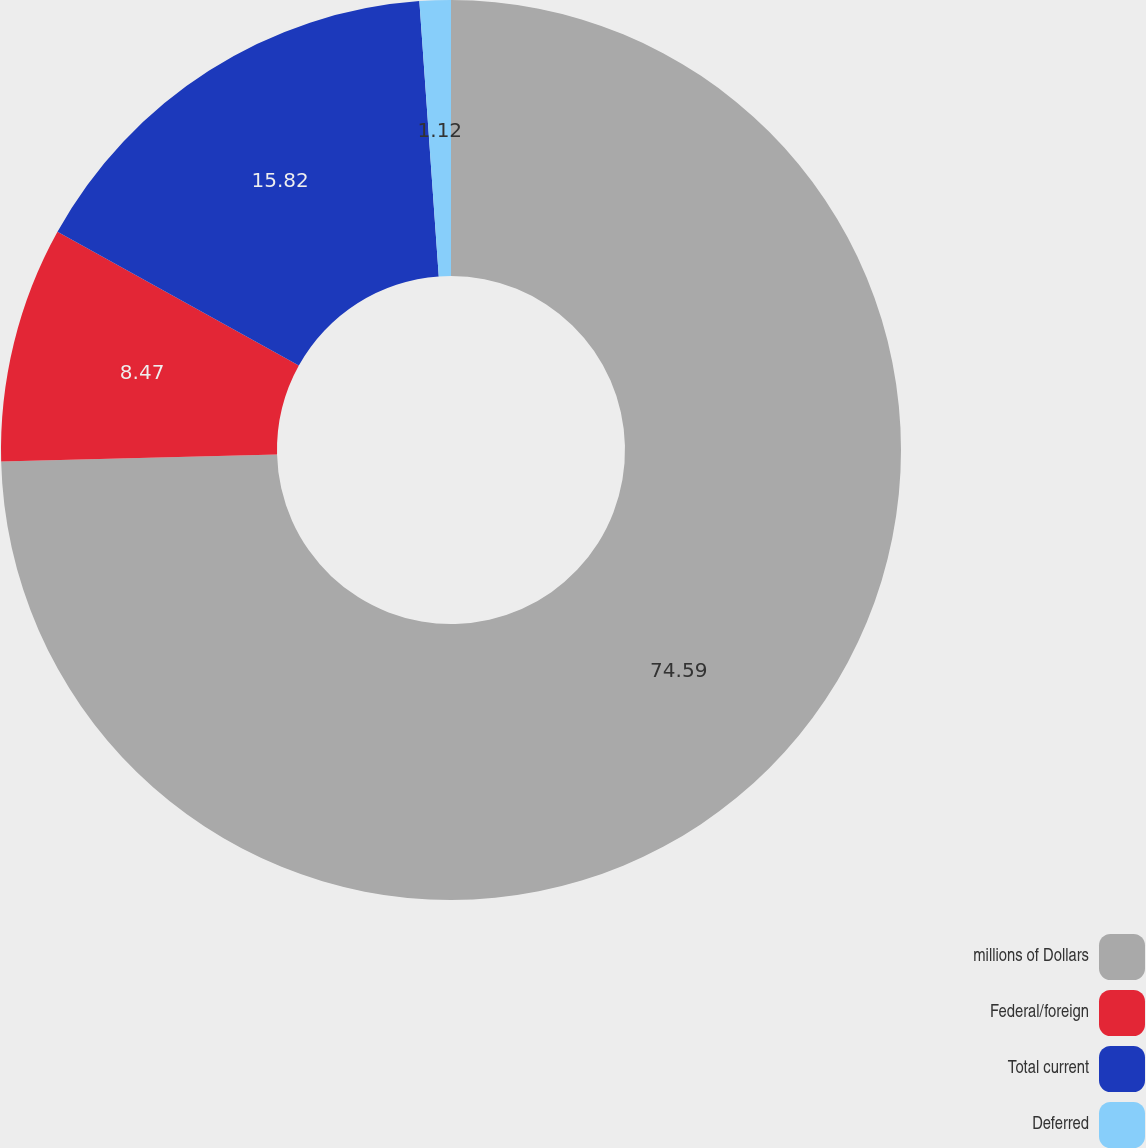<chart> <loc_0><loc_0><loc_500><loc_500><pie_chart><fcel>millions of Dollars<fcel>Federal/foreign<fcel>Total current<fcel>Deferred<nl><fcel>74.59%<fcel>8.47%<fcel>15.82%<fcel>1.12%<nl></chart> 